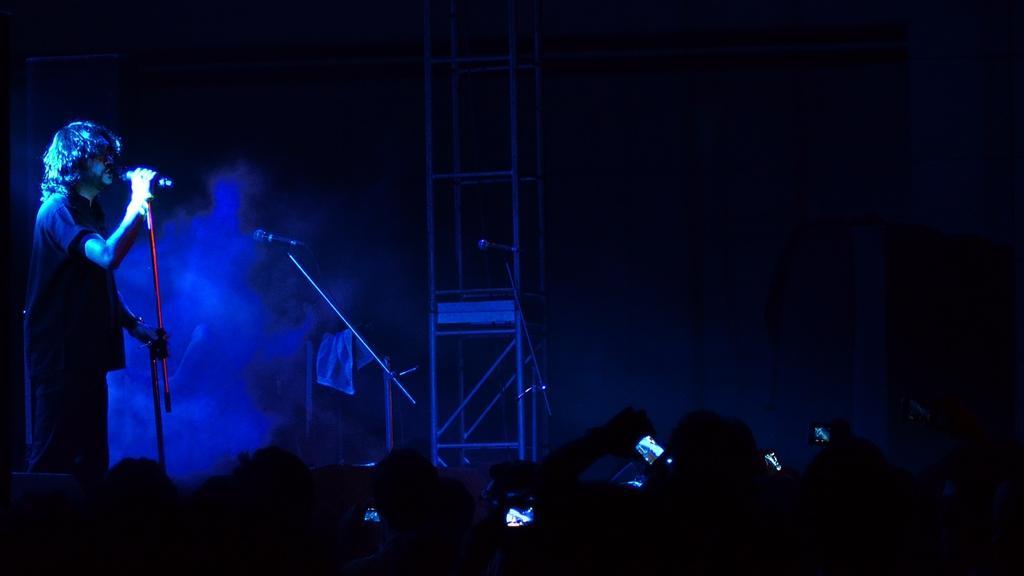Please provide a concise description of this image. At the bottom of the image few people are standing and holding mobile phones. On the left side of the image a man is standing and holding a microphone. Behind him there are some microphones. 